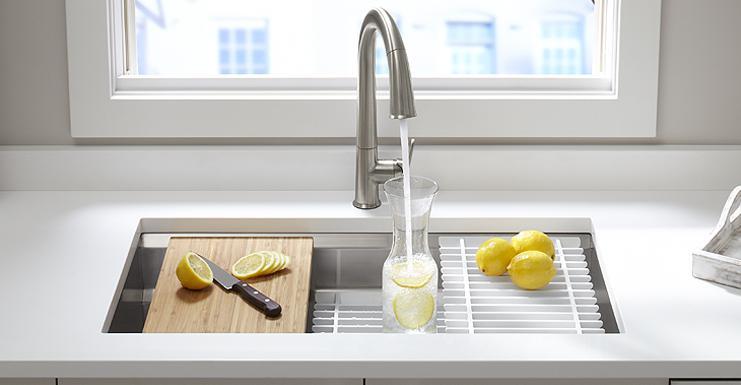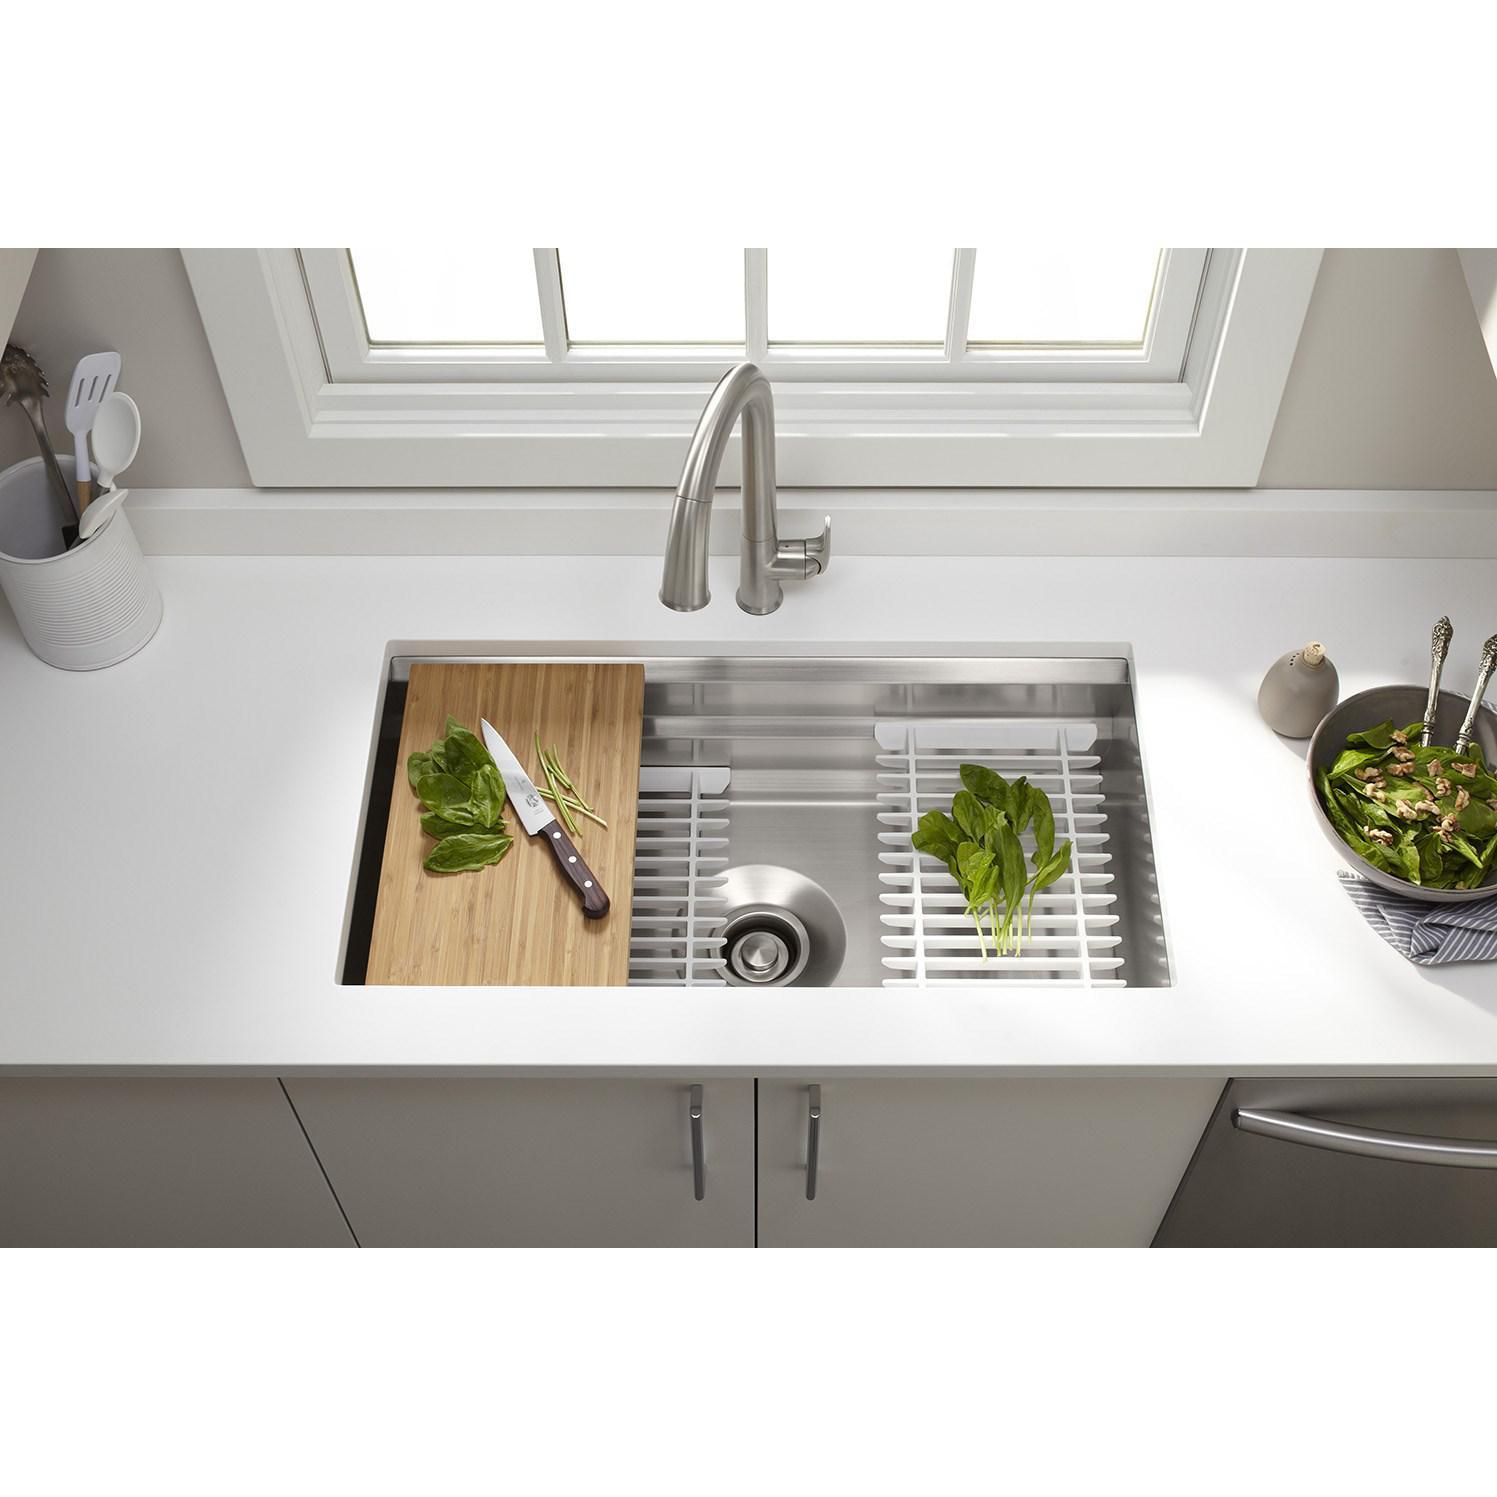The first image is the image on the left, the second image is the image on the right. Examine the images to the left and right. Is the description "A bottle is being filled with water from a faucet in the left image." accurate? Answer yes or no. Yes. The first image is the image on the left, the second image is the image on the right. Examine the images to the left and right. Is the description "A lemon sits on a white rack near the sink in one of the images." accurate? Answer yes or no. Yes. 